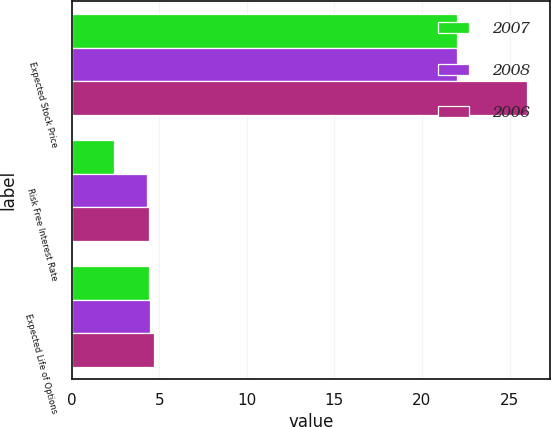Convert chart to OTSL. <chart><loc_0><loc_0><loc_500><loc_500><stacked_bar_chart><ecel><fcel>Expected Stock Price<fcel>Risk Free Interest Rate<fcel>Expected Life of Options<nl><fcel>2007<fcel>22<fcel>2.4<fcel>4.4<nl><fcel>2008<fcel>22<fcel>4.3<fcel>4.5<nl><fcel>2006<fcel>26<fcel>4.4<fcel>4.7<nl></chart> 